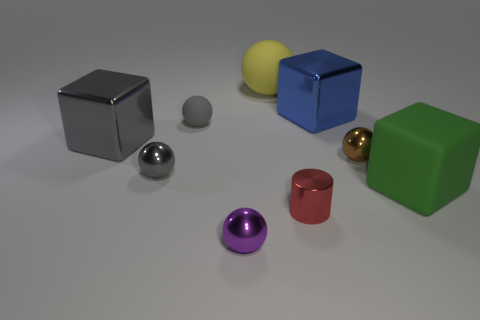Subtract all gray spheres. How many spheres are left? 3 Add 1 big gray spheres. How many objects exist? 10 Subtract all gray spheres. How many spheres are left? 3 Subtract all cyan spheres. Subtract all cyan blocks. How many spheres are left? 5 Add 2 small metallic objects. How many small metallic objects exist? 6 Subtract 0 yellow cylinders. How many objects are left? 9 Subtract all spheres. How many objects are left? 4 Subtract all large gray rubber things. Subtract all tiny gray balls. How many objects are left? 7 Add 1 large blue objects. How many large blue objects are left? 2 